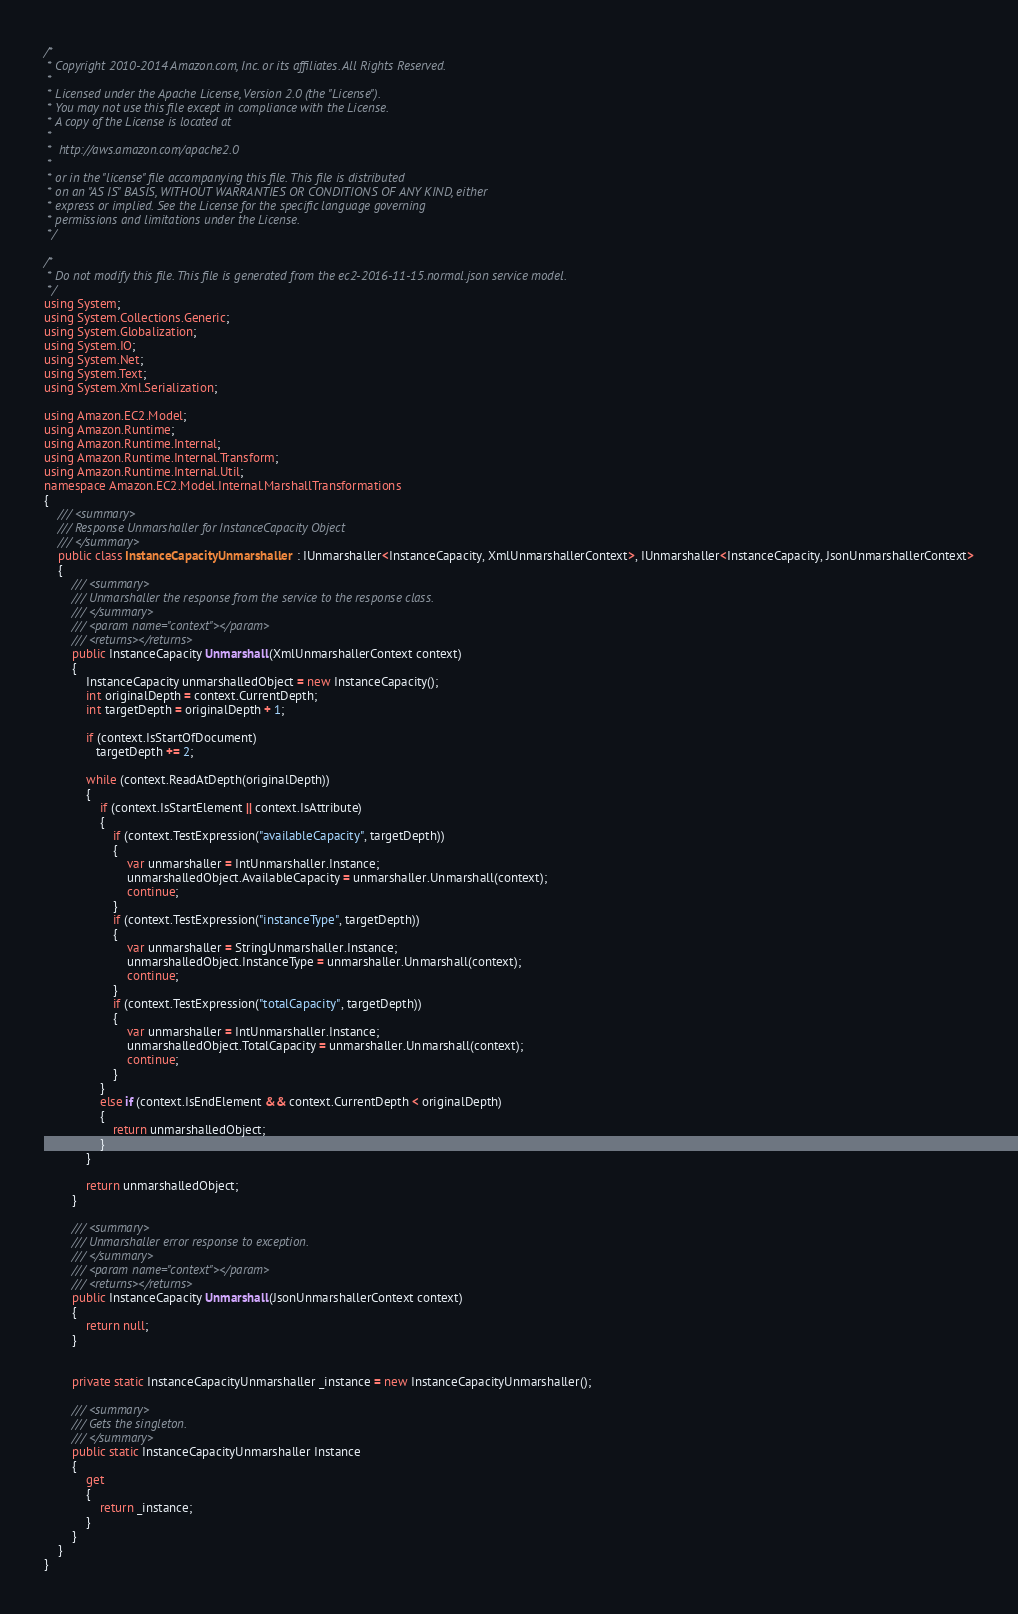Convert code to text. <code><loc_0><loc_0><loc_500><loc_500><_C#_>/*
 * Copyright 2010-2014 Amazon.com, Inc. or its affiliates. All Rights Reserved.
 * 
 * Licensed under the Apache License, Version 2.0 (the "License").
 * You may not use this file except in compliance with the License.
 * A copy of the License is located at
 * 
 *  http://aws.amazon.com/apache2.0
 * 
 * or in the "license" file accompanying this file. This file is distributed
 * on an "AS IS" BASIS, WITHOUT WARRANTIES OR CONDITIONS OF ANY KIND, either
 * express or implied. See the License for the specific language governing
 * permissions and limitations under the License.
 */

/*
 * Do not modify this file. This file is generated from the ec2-2016-11-15.normal.json service model.
 */
using System;
using System.Collections.Generic;
using System.Globalization;
using System.IO;
using System.Net;
using System.Text;
using System.Xml.Serialization;

using Amazon.EC2.Model;
using Amazon.Runtime;
using Amazon.Runtime.Internal;
using Amazon.Runtime.Internal.Transform;
using Amazon.Runtime.Internal.Util;
namespace Amazon.EC2.Model.Internal.MarshallTransformations
{
    /// <summary>
    /// Response Unmarshaller for InstanceCapacity Object
    /// </summary>  
    public class InstanceCapacityUnmarshaller : IUnmarshaller<InstanceCapacity, XmlUnmarshallerContext>, IUnmarshaller<InstanceCapacity, JsonUnmarshallerContext>
    {
        /// <summary>
        /// Unmarshaller the response from the service to the response class.
        /// </summary>  
        /// <param name="context"></param>
        /// <returns></returns>
        public InstanceCapacity Unmarshall(XmlUnmarshallerContext context)
        {
            InstanceCapacity unmarshalledObject = new InstanceCapacity();
            int originalDepth = context.CurrentDepth;
            int targetDepth = originalDepth + 1;
            
            if (context.IsStartOfDocument) 
               targetDepth += 2;
            
            while (context.ReadAtDepth(originalDepth))
            {
                if (context.IsStartElement || context.IsAttribute)
                {
                    if (context.TestExpression("availableCapacity", targetDepth))
                    {
                        var unmarshaller = IntUnmarshaller.Instance;
                        unmarshalledObject.AvailableCapacity = unmarshaller.Unmarshall(context);
                        continue;
                    }
                    if (context.TestExpression("instanceType", targetDepth))
                    {
                        var unmarshaller = StringUnmarshaller.Instance;
                        unmarshalledObject.InstanceType = unmarshaller.Unmarshall(context);
                        continue;
                    }
                    if (context.TestExpression("totalCapacity", targetDepth))
                    {
                        var unmarshaller = IntUnmarshaller.Instance;
                        unmarshalledObject.TotalCapacity = unmarshaller.Unmarshall(context);
                        continue;
                    }
                }
                else if (context.IsEndElement && context.CurrentDepth < originalDepth)
                {
                    return unmarshalledObject;
                }
            }

            return unmarshalledObject;
        }

        /// <summary>
        /// Unmarshaller error response to exception.
        /// </summary>  
        /// <param name="context"></param>
        /// <returns></returns>
        public InstanceCapacity Unmarshall(JsonUnmarshallerContext context)
        {
            return null;
        }


        private static InstanceCapacityUnmarshaller _instance = new InstanceCapacityUnmarshaller();        

        /// <summary>
        /// Gets the singleton.
        /// </summary>  
        public static InstanceCapacityUnmarshaller Instance
        {
            get
            {
                return _instance;
            }
        }
    }
}</code> 